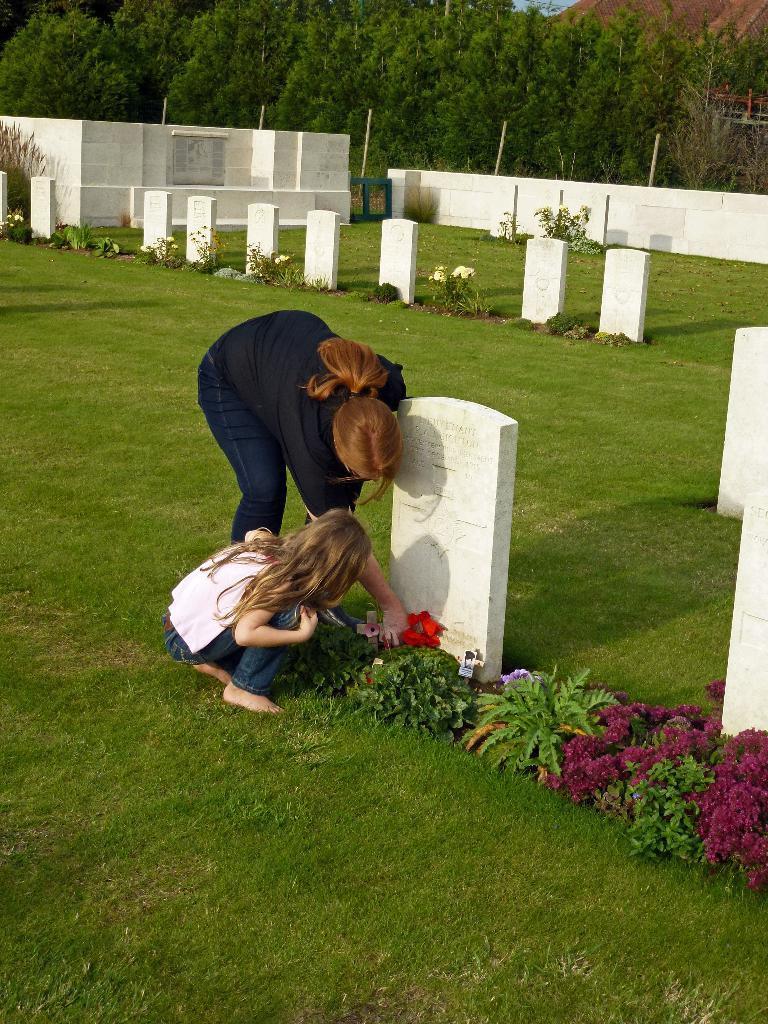In one or two sentences, can you explain what this image depicts? In this image I can see grass ground, tombstones, plants, flowers, shadows and here I can see two people. I can also see number of trees in background. 